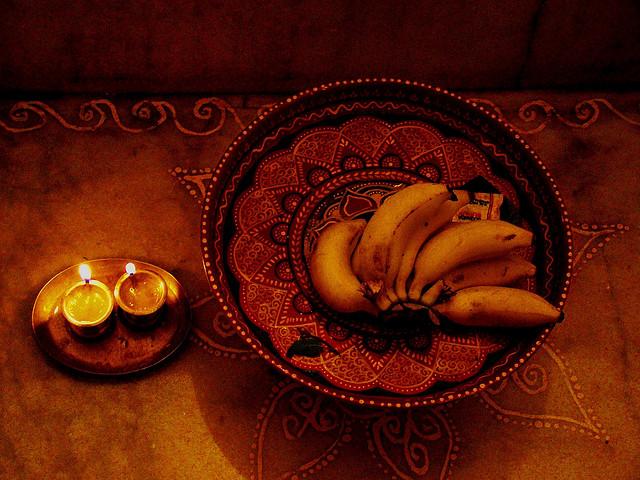What is this fruit?
Keep it brief. Banana. How many bananas are in the basket?
Be succinct. 6. What are these fruits?
Answer briefly. Bananas. Are these very large bananas?
Answer briefly. No. 